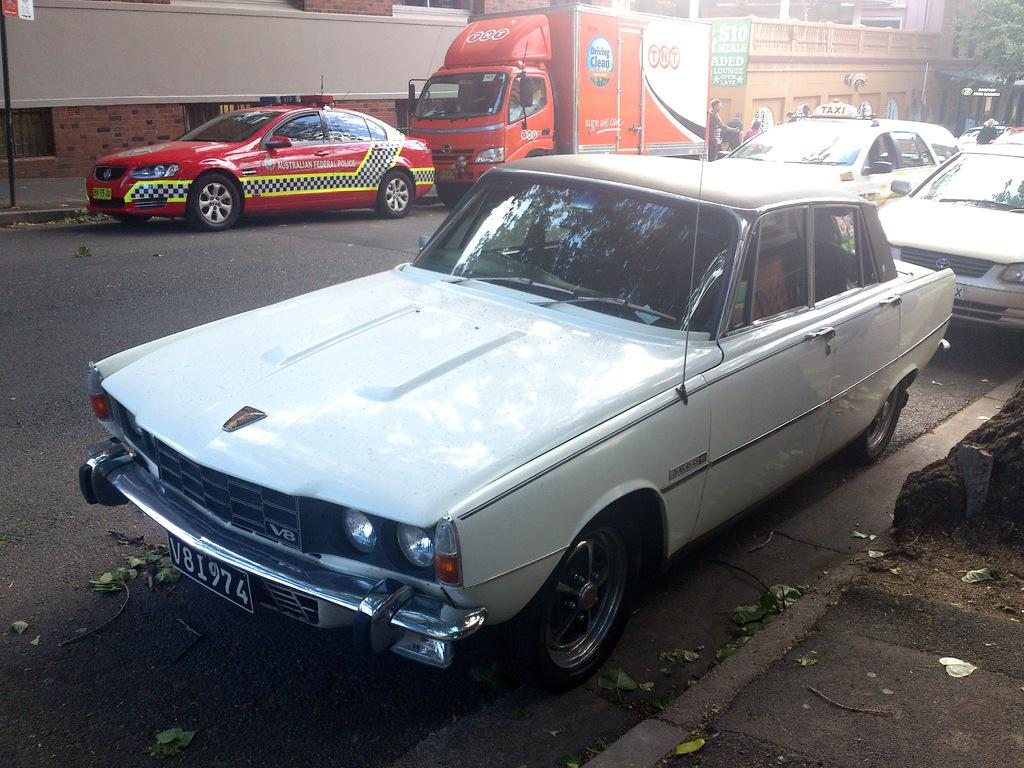What can be seen on the road in the image? There are cars on the road in the image. What is the person near in the image? The person is standing near a vehicle in the image. What type of structures are visible in the image? There are buildings in the image. What type of plant is present in the image? There is a tree in the image. What is attached to one of the buildings in the image? There is a poster attached to a building in the image. What sound can be heard coming from the zebra in the image? There is no zebra present in the image, so no sound can be heard from it. What type of service does the porter provide in the image? There is no porter present in the image, so no service can be provided. 